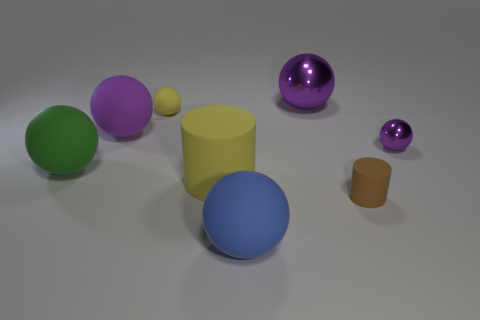How many yellow matte objects are the same size as the blue ball?
Your answer should be compact. 1. How big is the cylinder that is left of the small thing in front of the tiny purple metal object?
Your answer should be very brief. Large. There is a small matte object to the right of the tiny yellow matte thing; is it the same shape as the purple thing that is right of the big purple shiny sphere?
Provide a short and direct response. No. There is a matte object that is in front of the small metal thing and left of the small yellow sphere; what color is it?
Your response must be concise. Green. Is there a small thing that has the same color as the large cylinder?
Your answer should be compact. Yes. There is a small matte object that is left of the big metallic sphere; what is its color?
Provide a short and direct response. Yellow. Are there any yellow matte cylinders that are in front of the large purple thing in front of the big shiny object?
Offer a terse response. Yes. There is a tiny metallic thing; is its color the same as the large ball that is behind the tiny yellow rubber object?
Provide a succinct answer. Yes. Are there any large cyan objects that have the same material as the tiny purple ball?
Ensure brevity in your answer.  No. How many shiny balls are there?
Your response must be concise. 2. 